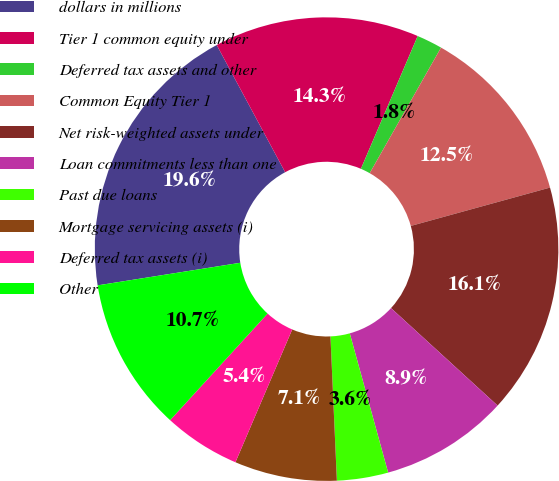Convert chart to OTSL. <chart><loc_0><loc_0><loc_500><loc_500><pie_chart><fcel>dollars in millions<fcel>Tier 1 common equity under<fcel>Deferred tax assets and other<fcel>Common Equity Tier 1<fcel>Net risk-weighted assets under<fcel>Loan commitments less than one<fcel>Past due loans<fcel>Mortgage servicing assets (i)<fcel>Deferred tax assets (i)<fcel>Other<nl><fcel>19.64%<fcel>14.29%<fcel>1.79%<fcel>12.5%<fcel>16.07%<fcel>8.93%<fcel>3.57%<fcel>7.14%<fcel>5.36%<fcel>10.71%<nl></chart> 